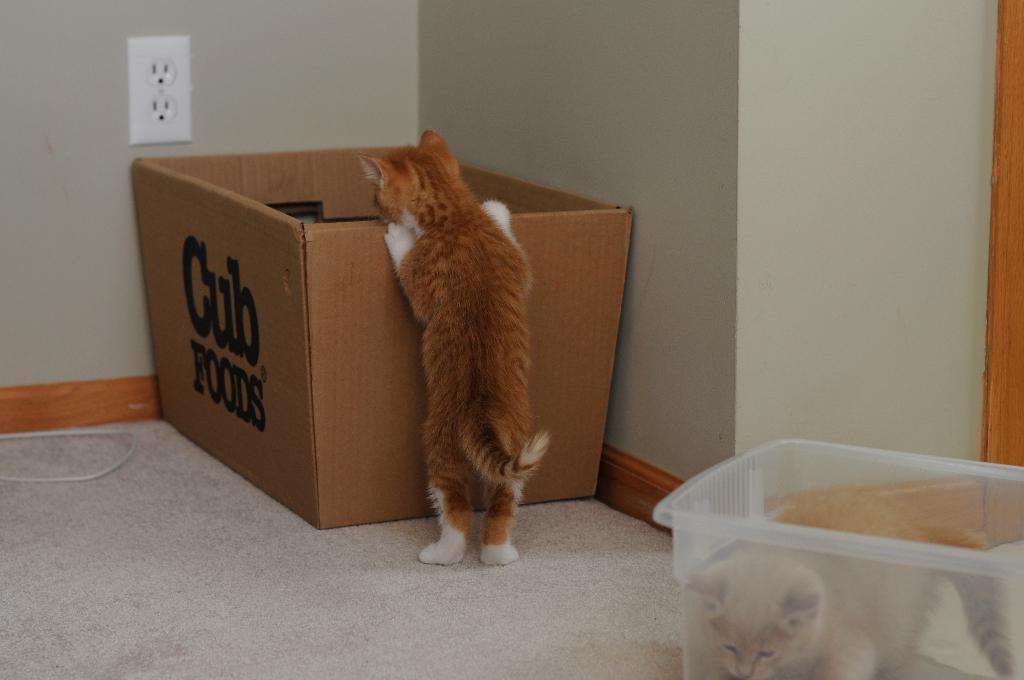What does the sign at the back say?
Your answer should be very brief. Cub foods. 